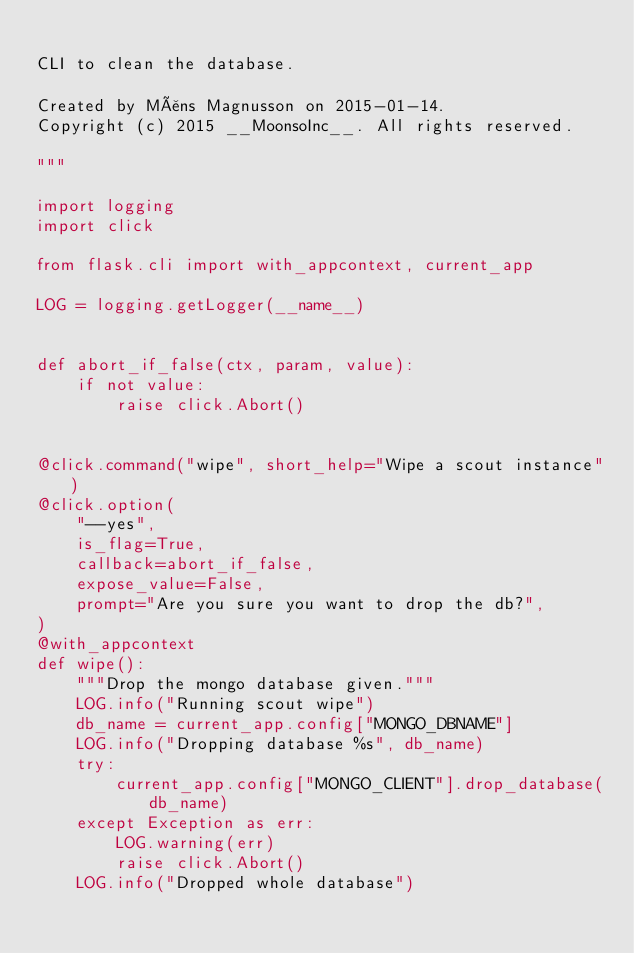Convert code to text. <code><loc_0><loc_0><loc_500><loc_500><_Python_>
CLI to clean the database.

Created by Måns Magnusson on 2015-01-14.
Copyright (c) 2015 __MoonsoInc__. All rights reserved.

"""

import logging
import click

from flask.cli import with_appcontext, current_app

LOG = logging.getLogger(__name__)


def abort_if_false(ctx, param, value):
    if not value:
        raise click.Abort()


@click.command("wipe", short_help="Wipe a scout instance")
@click.option(
    "--yes",
    is_flag=True,
    callback=abort_if_false,
    expose_value=False,
    prompt="Are you sure you want to drop the db?",
)
@with_appcontext
def wipe():
    """Drop the mongo database given."""
    LOG.info("Running scout wipe")
    db_name = current_app.config["MONGO_DBNAME"]
    LOG.info("Dropping database %s", db_name)
    try:
        current_app.config["MONGO_CLIENT"].drop_database(db_name)
    except Exception as err:
        LOG.warning(err)
        raise click.Abort()
    LOG.info("Dropped whole database")
</code> 